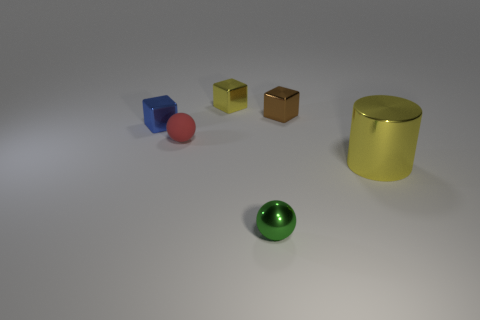Add 2 tiny cyan cylinders. How many objects exist? 8 Subtract all cylinders. How many objects are left? 5 Add 2 large yellow things. How many large yellow things exist? 3 Subtract 1 blue cubes. How many objects are left? 5 Subtract all small metal objects. Subtract all tiny red matte objects. How many objects are left? 1 Add 3 tiny brown shiny cubes. How many tiny brown shiny cubes are left? 4 